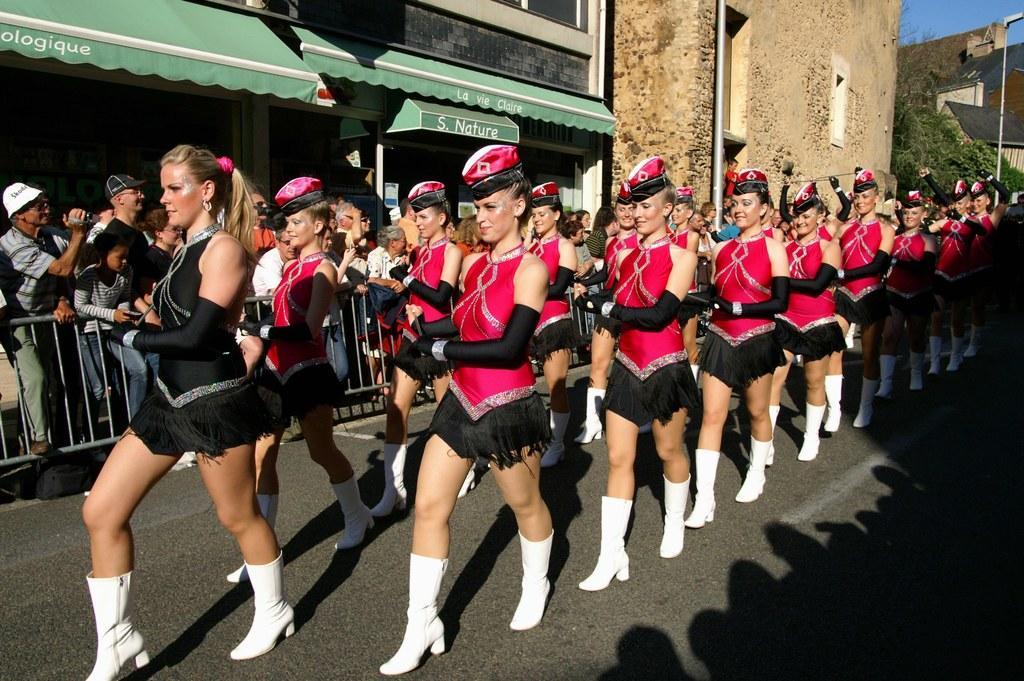How would you summarize this image in a sentence or two? In this image we can see ladies walking on the road. They are all wearing costumes. In the background there are buildings, trees, poles and sky. There is crowd and we can see a fence. 